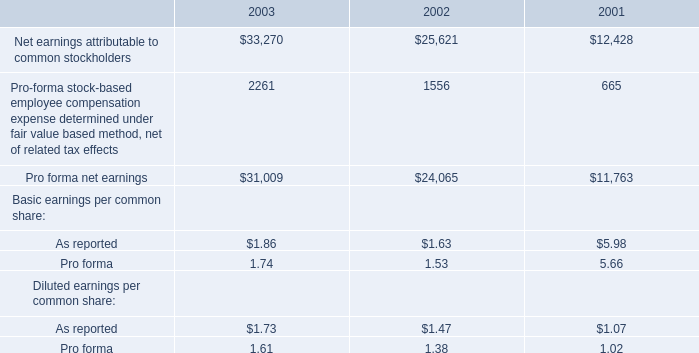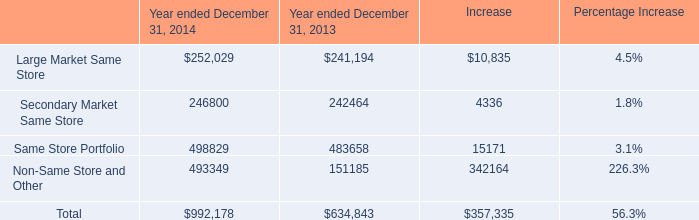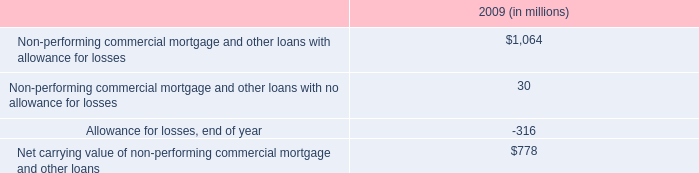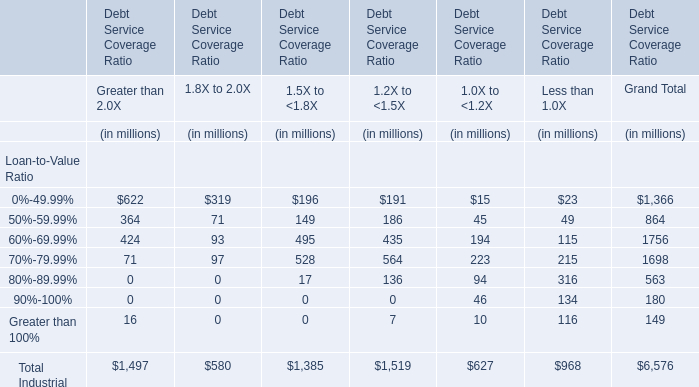What's the sum of Same Store Portfolio of Year ended December 31, 2014, and Pro forma net earnings of 2001 ? 
Computations: (498829.0 + 11763.0)
Answer: 510592.0. 